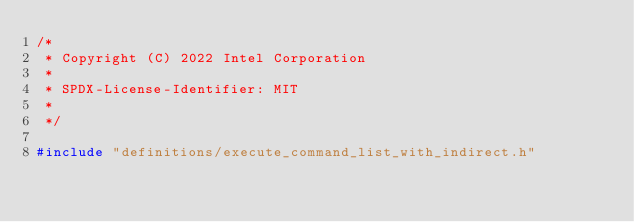Convert code to text. <code><loc_0><loc_0><loc_500><loc_500><_C++_>/*
 * Copyright (C) 2022 Intel Corporation
 *
 * SPDX-License-Identifier: MIT
 *
 */

#include "definitions/execute_command_list_with_indirect.h"
</code> 